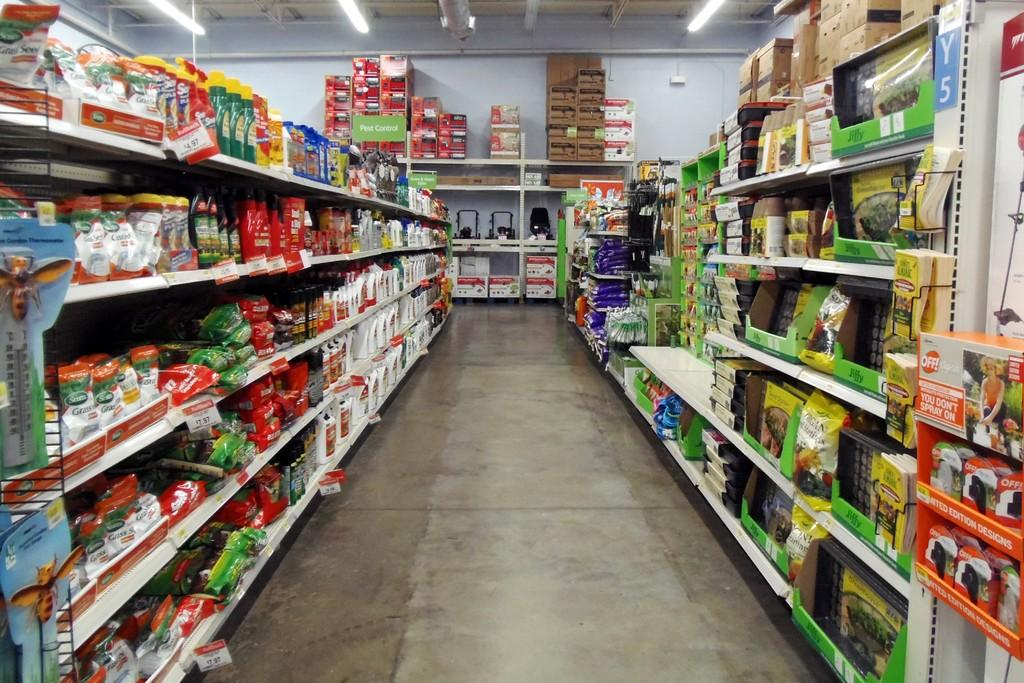<image>
Describe the image concisely. an aisle in a store with off! spray in the front of it 